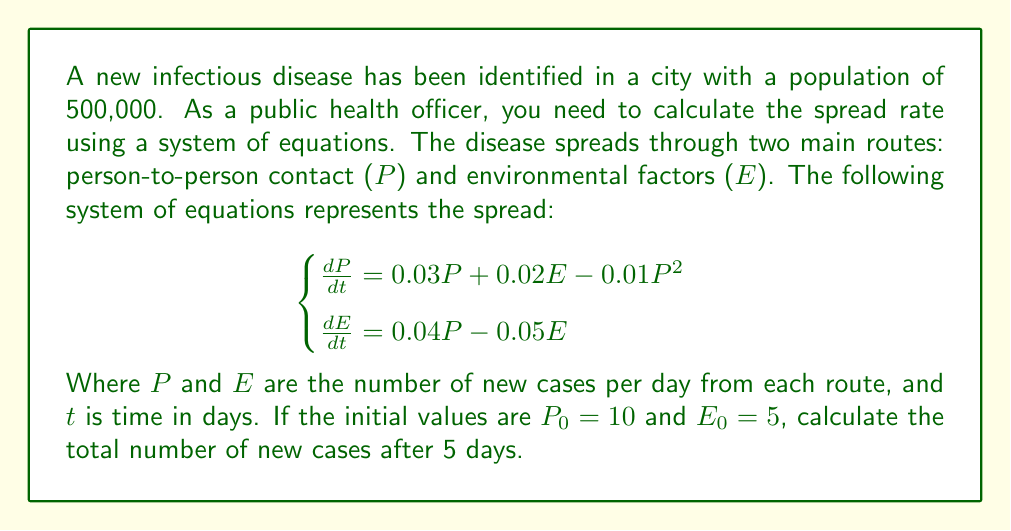Can you solve this math problem? To solve this problem, we need to use numerical methods to approximate the solution of the system of differential equations. We'll use the Euler method with a step size of 1 day.

Step 1: Set up the initial values and time step
$P_0 = 10$, $E_0 = 5$, $\Delta t = 1$ day, $t_{final} = 5$ days

Step 2: Define the functions for $\frac{dP}{dt}$ and $\frac{dE}{dt}$
$f_P(P, E) = 0.03P + 0.02E - 0.01P^2$
$f_E(P, E) = 0.04P - 0.05E$

Step 3: Apply the Euler method for each day
For $i = 1$ to $5$:
$P_i = P_{i-1} + \Delta t \cdot f_P(P_{i-1}, E_{i-1})$
$E_i = E_{i-1} + \Delta t \cdot f_E(P_{i-1}, E_{i-1})$

Day 1:
$P_1 = 10 + 1 \cdot (0.03 \cdot 10 + 0.02 \cdot 5 - 0.01 \cdot 10^2) = 10.4$
$E_1 = 5 + 1 \cdot (0.04 \cdot 10 - 0.05 \cdot 5) = 5.15$

Day 2:
$P_2 = 10.4 + 1 \cdot (0.03 \cdot 10.4 + 0.02 \cdot 5.15 - 0.01 \cdot 10.4^2) = 10.8216$
$E_2 = 5.15 + 1 \cdot (0.04 \cdot 10.4 - 0.05 \cdot 5.15) = 5.3065$

Day 3:
$P_3 = 11.2669$
$E_3 = 5.4714$

Day 4:
$P_4 = 11.7372$
$E_4 = 5.6450$

Day 5:
$P_5 = 12.2339$
$E_5 = 5.8277$

Step 4: Calculate the total number of new cases
Total new cases = $P_5 + E_5 = 12.2339 + 5.8277 = 18.0616$

Round to the nearest whole number: 19 new cases
Answer: 19 new cases 